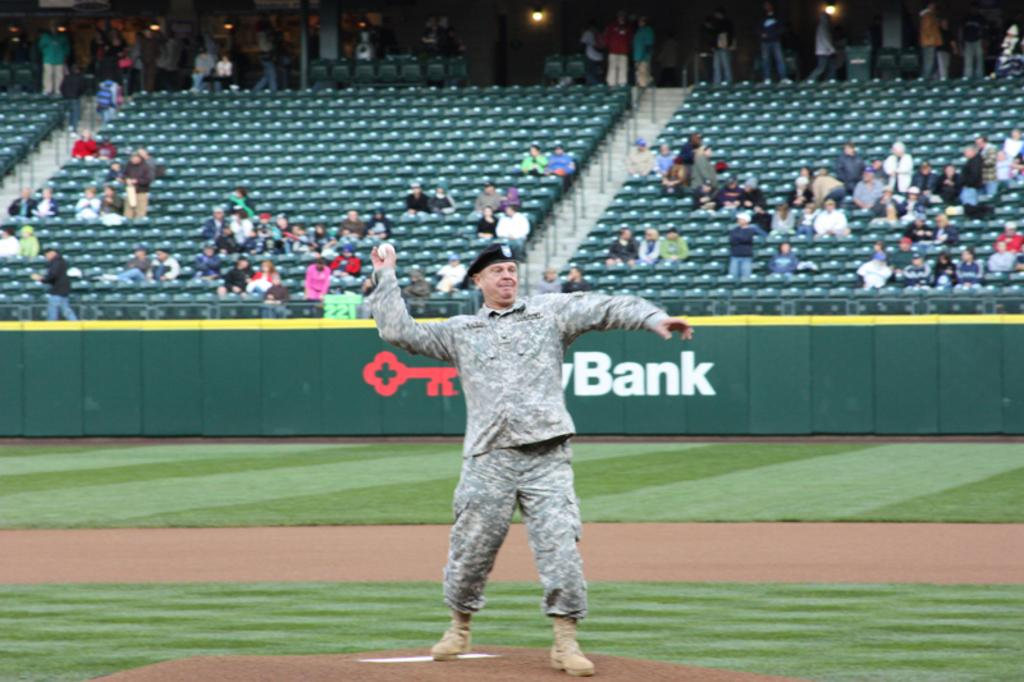<image>
Write a terse but informative summary of the picture. man wearing military uniform throwing ball and bank logo is visible behind him 